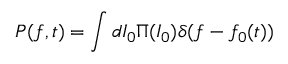<formula> <loc_0><loc_0><loc_500><loc_500>P ( f , t ) = \int d I _ { 0 } \Pi ( I _ { 0 } ) \delta ( f - f _ { 0 } ( t ) )</formula> 